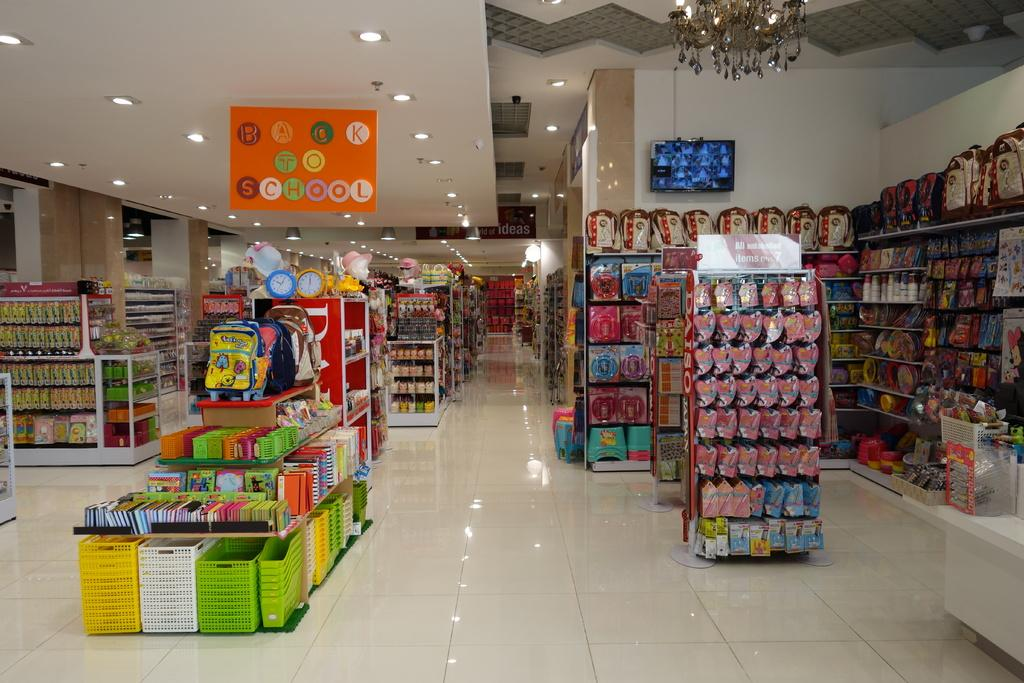<image>
Provide a brief description of the given image. The inside of a store stocked with items for going back to school. 